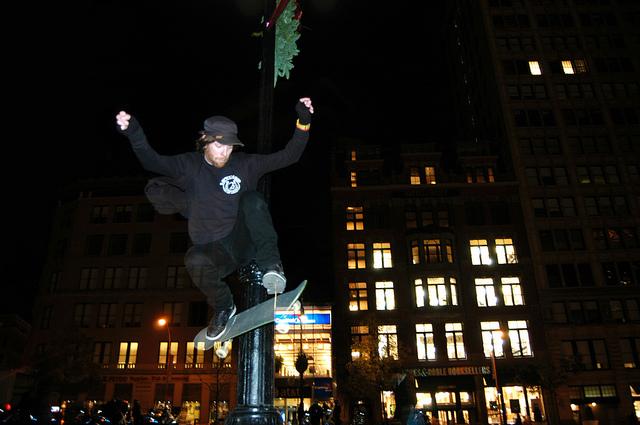What color are the men's gloves?
Quick response, please. Black. Is the board transparent?
Write a very short answer. Yes. What is the man doing?
Quick response, please. Skateboarding. 